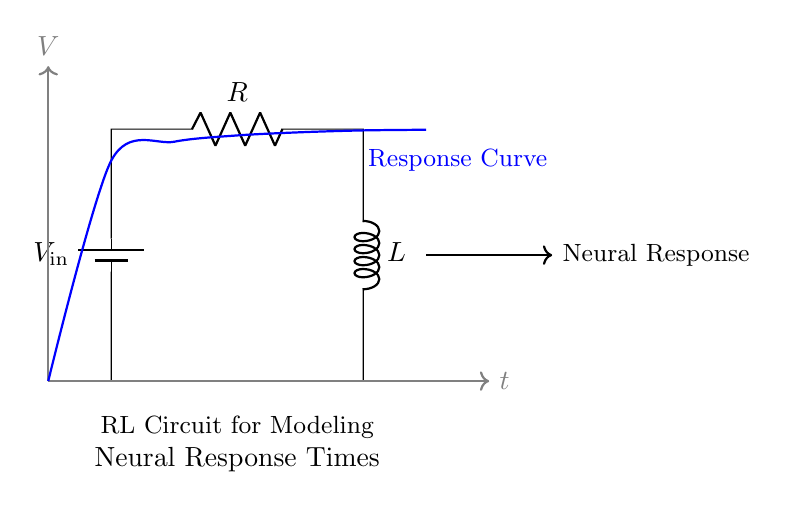What components are in this circuit? The circuit contains a battery, a resistor, and an inductor. These components are connected in series to form an RL circuit for modeling responses.
Answer: battery, resistor, inductor What is the function of the resistor in this RL circuit? The resistor limits the current flow in the circuit and dissipates energy as heat. It plays a critical role in influencing the time constant of the circuit, which affects how the system responds over time.
Answer: limits current What is the role of the inductor in this circuit? The inductor stores energy in a magnetic field when current flows through it and resists changes in current. This behavior is crucial for modeling the lag in neural response times.
Answer: stores energy What is the voltage named in the diagram? The voltage is labeled as V in the circuit diagram, and it represents the potential difference driving the current through the components.
Answer: V What does the response curve indicate about neural response times? The response curve illustrates how response time evolves over time after the application of stimuli. It shows the gradual increase in response as influenced by the resistor and inductor characteristics.
Answer: response time evolution What does the RL circuit model in psychological research? The RL circuit models the time delay and gradual increase in neural response times, reflecting the dynamics of brain activity in processing stimuli.
Answer: neural response times How does the resistor value affect the time constant of the circuit? The time constant of an RL circuit, which influences how quickly current builds up, is dependent on both the resistance and inductance. A higher resistance results in a longer time constant, slowing the response time.
Answer: increases time constant 